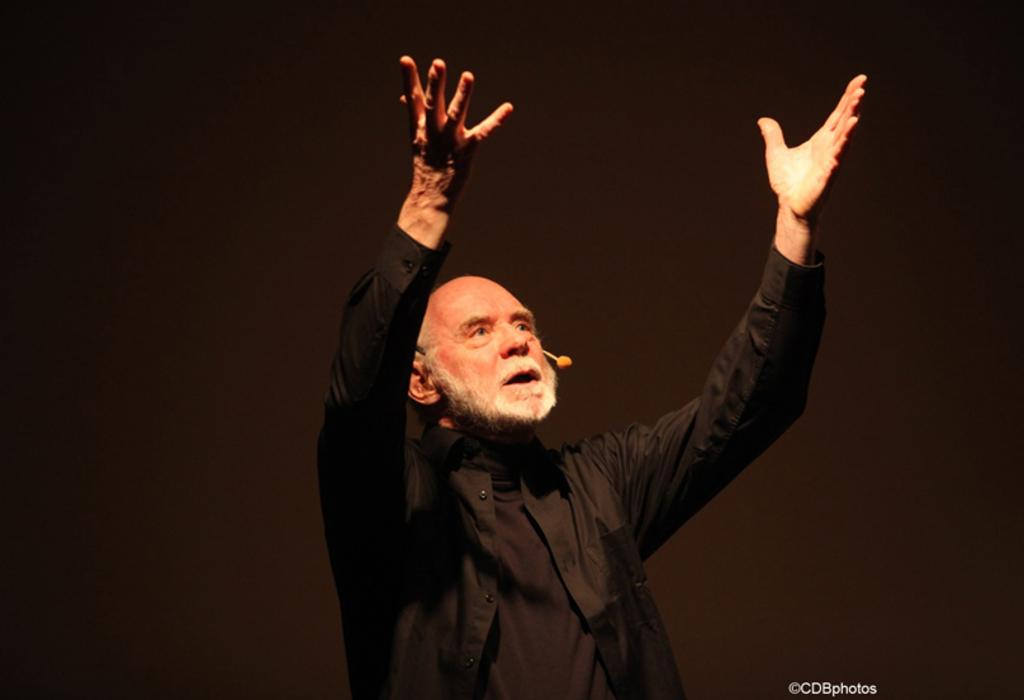What is the man in the image doing with his hands? The man is raising his hands in the image. What is the man wearing in the image? The man is wearing a black shirt in the image. What can be observed about the background of the image? The background of the image appears to be black. Is there any additional information or marking on the image? Yes, there is a watermark at the bottom of the image. What type of pain is the man experiencing in the image? There is no indication of pain in the image; the man is simply raising his hands. 